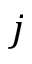Convert formula to latex. <formula><loc_0><loc_0><loc_500><loc_500>j</formula> 